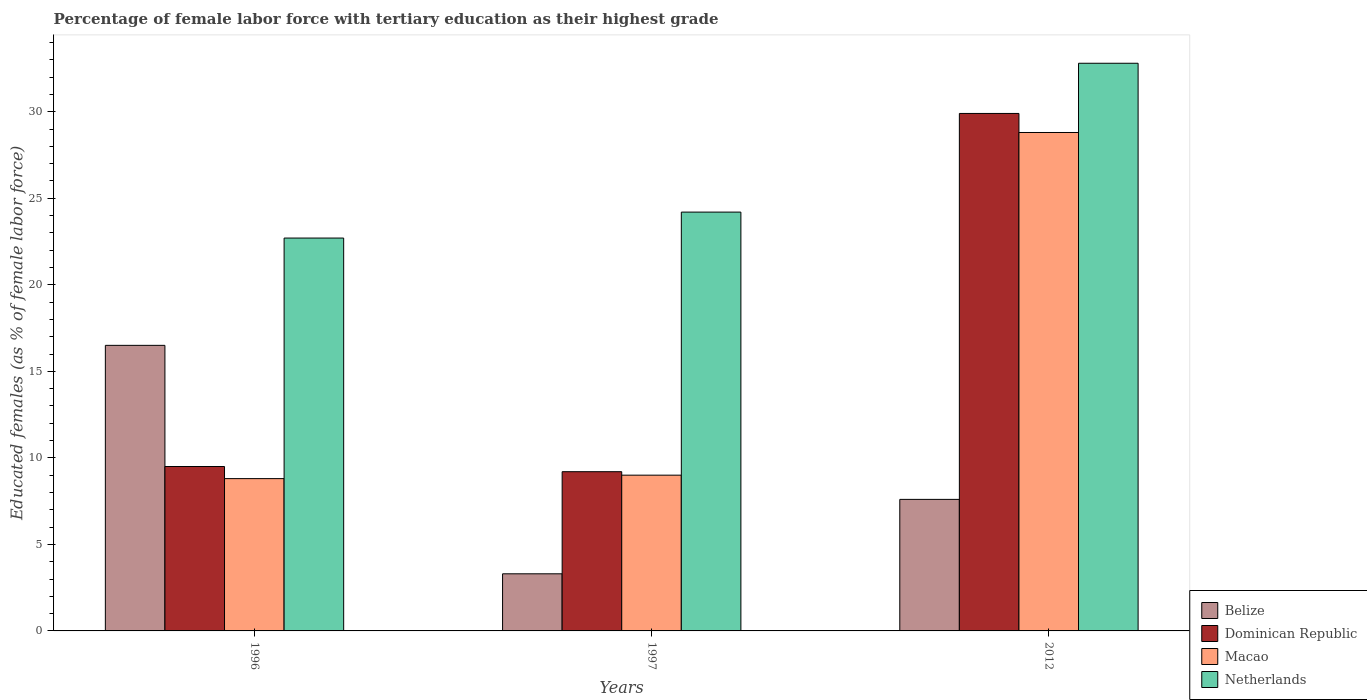Are the number of bars per tick equal to the number of legend labels?
Keep it short and to the point. Yes. How many bars are there on the 2nd tick from the left?
Make the answer very short. 4. How many bars are there on the 2nd tick from the right?
Your answer should be very brief. 4. In how many cases, is the number of bars for a given year not equal to the number of legend labels?
Your answer should be very brief. 0. What is the percentage of female labor force with tertiary education in Dominican Republic in 1996?
Provide a short and direct response. 9.5. Across all years, what is the maximum percentage of female labor force with tertiary education in Dominican Republic?
Your answer should be very brief. 29.9. Across all years, what is the minimum percentage of female labor force with tertiary education in Belize?
Give a very brief answer. 3.3. In which year was the percentage of female labor force with tertiary education in Dominican Republic maximum?
Provide a short and direct response. 2012. In which year was the percentage of female labor force with tertiary education in Dominican Republic minimum?
Give a very brief answer. 1997. What is the total percentage of female labor force with tertiary education in Macao in the graph?
Your answer should be very brief. 46.6. What is the difference between the percentage of female labor force with tertiary education in Belize in 1997 and the percentage of female labor force with tertiary education in Dominican Republic in 1996?
Provide a succinct answer. -6.2. What is the average percentage of female labor force with tertiary education in Netherlands per year?
Give a very brief answer. 26.57. In the year 1996, what is the difference between the percentage of female labor force with tertiary education in Dominican Republic and percentage of female labor force with tertiary education in Belize?
Offer a terse response. -7. What is the ratio of the percentage of female labor force with tertiary education in Belize in 1997 to that in 2012?
Offer a terse response. 0.43. What is the difference between the highest and the second highest percentage of female labor force with tertiary education in Macao?
Make the answer very short. 19.8. What is the difference between the highest and the lowest percentage of female labor force with tertiary education in Netherlands?
Your answer should be very brief. 10.1. In how many years, is the percentage of female labor force with tertiary education in Macao greater than the average percentage of female labor force with tertiary education in Macao taken over all years?
Provide a short and direct response. 1. Is the sum of the percentage of female labor force with tertiary education in Netherlands in 1996 and 2012 greater than the maximum percentage of female labor force with tertiary education in Macao across all years?
Your response must be concise. Yes. Is it the case that in every year, the sum of the percentage of female labor force with tertiary education in Macao and percentage of female labor force with tertiary education in Belize is greater than the sum of percentage of female labor force with tertiary education in Dominican Republic and percentage of female labor force with tertiary education in Netherlands?
Provide a succinct answer. No. What does the 3rd bar from the right in 1996 represents?
Make the answer very short. Dominican Republic. Is it the case that in every year, the sum of the percentage of female labor force with tertiary education in Macao and percentage of female labor force with tertiary education in Netherlands is greater than the percentage of female labor force with tertiary education in Belize?
Provide a succinct answer. Yes. How many years are there in the graph?
Your answer should be very brief. 3. Does the graph contain grids?
Give a very brief answer. No. Where does the legend appear in the graph?
Make the answer very short. Bottom right. How are the legend labels stacked?
Give a very brief answer. Vertical. What is the title of the graph?
Your answer should be very brief. Percentage of female labor force with tertiary education as their highest grade. Does "Finland" appear as one of the legend labels in the graph?
Your response must be concise. No. What is the label or title of the Y-axis?
Give a very brief answer. Educated females (as % of female labor force). What is the Educated females (as % of female labor force) in Belize in 1996?
Give a very brief answer. 16.5. What is the Educated females (as % of female labor force) of Macao in 1996?
Keep it short and to the point. 8.8. What is the Educated females (as % of female labor force) in Netherlands in 1996?
Provide a short and direct response. 22.7. What is the Educated females (as % of female labor force) of Belize in 1997?
Make the answer very short. 3.3. What is the Educated females (as % of female labor force) in Dominican Republic in 1997?
Your answer should be compact. 9.2. What is the Educated females (as % of female labor force) of Netherlands in 1997?
Offer a very short reply. 24.2. What is the Educated females (as % of female labor force) in Belize in 2012?
Your response must be concise. 7.6. What is the Educated females (as % of female labor force) of Dominican Republic in 2012?
Your answer should be very brief. 29.9. What is the Educated females (as % of female labor force) of Macao in 2012?
Ensure brevity in your answer.  28.8. What is the Educated females (as % of female labor force) in Netherlands in 2012?
Provide a short and direct response. 32.8. Across all years, what is the maximum Educated females (as % of female labor force) of Belize?
Offer a very short reply. 16.5. Across all years, what is the maximum Educated females (as % of female labor force) in Dominican Republic?
Offer a very short reply. 29.9. Across all years, what is the maximum Educated females (as % of female labor force) in Macao?
Keep it short and to the point. 28.8. Across all years, what is the maximum Educated females (as % of female labor force) of Netherlands?
Offer a very short reply. 32.8. Across all years, what is the minimum Educated females (as % of female labor force) in Belize?
Make the answer very short. 3.3. Across all years, what is the minimum Educated females (as % of female labor force) of Dominican Republic?
Offer a terse response. 9.2. Across all years, what is the minimum Educated females (as % of female labor force) of Macao?
Give a very brief answer. 8.8. Across all years, what is the minimum Educated females (as % of female labor force) of Netherlands?
Offer a terse response. 22.7. What is the total Educated females (as % of female labor force) in Belize in the graph?
Give a very brief answer. 27.4. What is the total Educated females (as % of female labor force) of Dominican Republic in the graph?
Offer a terse response. 48.6. What is the total Educated females (as % of female labor force) of Macao in the graph?
Your response must be concise. 46.6. What is the total Educated females (as % of female labor force) of Netherlands in the graph?
Provide a short and direct response. 79.7. What is the difference between the Educated females (as % of female labor force) in Dominican Republic in 1996 and that in 1997?
Make the answer very short. 0.3. What is the difference between the Educated females (as % of female labor force) in Macao in 1996 and that in 1997?
Ensure brevity in your answer.  -0.2. What is the difference between the Educated females (as % of female labor force) in Netherlands in 1996 and that in 1997?
Ensure brevity in your answer.  -1.5. What is the difference between the Educated females (as % of female labor force) in Belize in 1996 and that in 2012?
Your response must be concise. 8.9. What is the difference between the Educated females (as % of female labor force) in Dominican Republic in 1996 and that in 2012?
Your answer should be compact. -20.4. What is the difference between the Educated females (as % of female labor force) of Macao in 1996 and that in 2012?
Offer a very short reply. -20. What is the difference between the Educated females (as % of female labor force) of Belize in 1997 and that in 2012?
Offer a terse response. -4.3. What is the difference between the Educated females (as % of female labor force) of Dominican Republic in 1997 and that in 2012?
Your response must be concise. -20.7. What is the difference between the Educated females (as % of female labor force) of Macao in 1997 and that in 2012?
Make the answer very short. -19.8. What is the difference between the Educated females (as % of female labor force) in Belize in 1996 and the Educated females (as % of female labor force) in Macao in 1997?
Offer a terse response. 7.5. What is the difference between the Educated females (as % of female labor force) of Belize in 1996 and the Educated females (as % of female labor force) of Netherlands in 1997?
Give a very brief answer. -7.7. What is the difference between the Educated females (as % of female labor force) of Dominican Republic in 1996 and the Educated females (as % of female labor force) of Netherlands in 1997?
Make the answer very short. -14.7. What is the difference between the Educated females (as % of female labor force) in Macao in 1996 and the Educated females (as % of female labor force) in Netherlands in 1997?
Keep it short and to the point. -15.4. What is the difference between the Educated females (as % of female labor force) of Belize in 1996 and the Educated females (as % of female labor force) of Macao in 2012?
Provide a short and direct response. -12.3. What is the difference between the Educated females (as % of female labor force) in Belize in 1996 and the Educated females (as % of female labor force) in Netherlands in 2012?
Your answer should be compact. -16.3. What is the difference between the Educated females (as % of female labor force) of Dominican Republic in 1996 and the Educated females (as % of female labor force) of Macao in 2012?
Make the answer very short. -19.3. What is the difference between the Educated females (as % of female labor force) of Dominican Republic in 1996 and the Educated females (as % of female labor force) of Netherlands in 2012?
Ensure brevity in your answer.  -23.3. What is the difference between the Educated females (as % of female labor force) of Belize in 1997 and the Educated females (as % of female labor force) of Dominican Republic in 2012?
Offer a very short reply. -26.6. What is the difference between the Educated females (as % of female labor force) in Belize in 1997 and the Educated females (as % of female labor force) in Macao in 2012?
Your response must be concise. -25.5. What is the difference between the Educated females (as % of female labor force) in Belize in 1997 and the Educated females (as % of female labor force) in Netherlands in 2012?
Your response must be concise. -29.5. What is the difference between the Educated females (as % of female labor force) in Dominican Republic in 1997 and the Educated females (as % of female labor force) in Macao in 2012?
Your answer should be compact. -19.6. What is the difference between the Educated females (as % of female labor force) of Dominican Republic in 1997 and the Educated females (as % of female labor force) of Netherlands in 2012?
Offer a very short reply. -23.6. What is the difference between the Educated females (as % of female labor force) in Macao in 1997 and the Educated females (as % of female labor force) in Netherlands in 2012?
Keep it short and to the point. -23.8. What is the average Educated females (as % of female labor force) in Belize per year?
Keep it short and to the point. 9.13. What is the average Educated females (as % of female labor force) in Macao per year?
Offer a terse response. 15.53. What is the average Educated females (as % of female labor force) in Netherlands per year?
Offer a terse response. 26.57. In the year 1996, what is the difference between the Educated females (as % of female labor force) of Belize and Educated females (as % of female labor force) of Dominican Republic?
Your answer should be compact. 7. In the year 1996, what is the difference between the Educated females (as % of female labor force) in Belize and Educated females (as % of female labor force) in Netherlands?
Offer a terse response. -6.2. In the year 1996, what is the difference between the Educated females (as % of female labor force) in Dominican Republic and Educated females (as % of female labor force) in Macao?
Offer a terse response. 0.7. In the year 1996, what is the difference between the Educated females (as % of female labor force) of Dominican Republic and Educated females (as % of female labor force) of Netherlands?
Offer a very short reply. -13.2. In the year 1996, what is the difference between the Educated females (as % of female labor force) in Macao and Educated females (as % of female labor force) in Netherlands?
Your answer should be compact. -13.9. In the year 1997, what is the difference between the Educated females (as % of female labor force) of Belize and Educated females (as % of female labor force) of Macao?
Provide a succinct answer. -5.7. In the year 1997, what is the difference between the Educated females (as % of female labor force) of Belize and Educated females (as % of female labor force) of Netherlands?
Provide a succinct answer. -20.9. In the year 1997, what is the difference between the Educated females (as % of female labor force) of Dominican Republic and Educated females (as % of female labor force) of Macao?
Give a very brief answer. 0.2. In the year 1997, what is the difference between the Educated females (as % of female labor force) in Dominican Republic and Educated females (as % of female labor force) in Netherlands?
Provide a short and direct response. -15. In the year 1997, what is the difference between the Educated females (as % of female labor force) in Macao and Educated females (as % of female labor force) in Netherlands?
Keep it short and to the point. -15.2. In the year 2012, what is the difference between the Educated females (as % of female labor force) of Belize and Educated females (as % of female labor force) of Dominican Republic?
Provide a short and direct response. -22.3. In the year 2012, what is the difference between the Educated females (as % of female labor force) in Belize and Educated females (as % of female labor force) in Macao?
Your response must be concise. -21.2. In the year 2012, what is the difference between the Educated females (as % of female labor force) in Belize and Educated females (as % of female labor force) in Netherlands?
Offer a terse response. -25.2. In the year 2012, what is the difference between the Educated females (as % of female labor force) of Dominican Republic and Educated females (as % of female labor force) of Netherlands?
Offer a terse response. -2.9. In the year 2012, what is the difference between the Educated females (as % of female labor force) in Macao and Educated females (as % of female labor force) in Netherlands?
Provide a succinct answer. -4. What is the ratio of the Educated females (as % of female labor force) of Dominican Republic in 1996 to that in 1997?
Offer a very short reply. 1.03. What is the ratio of the Educated females (as % of female labor force) of Macao in 1996 to that in 1997?
Your answer should be compact. 0.98. What is the ratio of the Educated females (as % of female labor force) of Netherlands in 1996 to that in 1997?
Make the answer very short. 0.94. What is the ratio of the Educated females (as % of female labor force) in Belize in 1996 to that in 2012?
Offer a very short reply. 2.17. What is the ratio of the Educated females (as % of female labor force) in Dominican Republic in 1996 to that in 2012?
Provide a short and direct response. 0.32. What is the ratio of the Educated females (as % of female labor force) in Macao in 1996 to that in 2012?
Provide a short and direct response. 0.31. What is the ratio of the Educated females (as % of female labor force) of Netherlands in 1996 to that in 2012?
Offer a terse response. 0.69. What is the ratio of the Educated females (as % of female labor force) of Belize in 1997 to that in 2012?
Your answer should be compact. 0.43. What is the ratio of the Educated females (as % of female labor force) of Dominican Republic in 1997 to that in 2012?
Your response must be concise. 0.31. What is the ratio of the Educated females (as % of female labor force) in Macao in 1997 to that in 2012?
Keep it short and to the point. 0.31. What is the ratio of the Educated females (as % of female labor force) in Netherlands in 1997 to that in 2012?
Your answer should be very brief. 0.74. What is the difference between the highest and the second highest Educated females (as % of female labor force) of Belize?
Your answer should be very brief. 8.9. What is the difference between the highest and the second highest Educated females (as % of female labor force) of Dominican Republic?
Give a very brief answer. 20.4. What is the difference between the highest and the second highest Educated females (as % of female labor force) of Macao?
Keep it short and to the point. 19.8. What is the difference between the highest and the lowest Educated females (as % of female labor force) of Dominican Republic?
Give a very brief answer. 20.7. What is the difference between the highest and the lowest Educated females (as % of female labor force) of Macao?
Your answer should be compact. 20. What is the difference between the highest and the lowest Educated females (as % of female labor force) in Netherlands?
Your response must be concise. 10.1. 